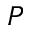Convert formula to latex. <formula><loc_0><loc_0><loc_500><loc_500>P</formula> 